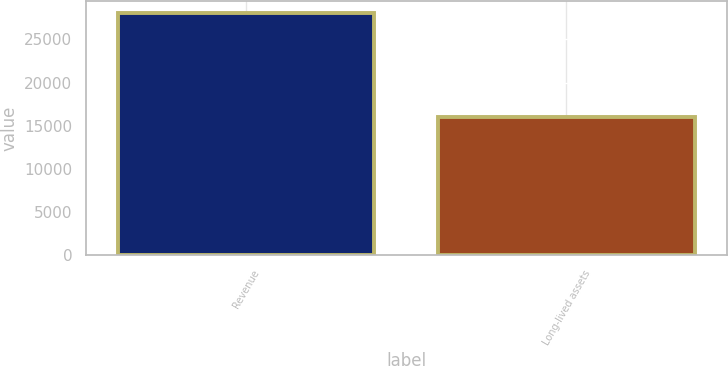Convert chart. <chart><loc_0><loc_0><loc_500><loc_500><bar_chart><fcel>Revenue<fcel>Long-lived assets<nl><fcel>28035<fcel>16033<nl></chart> 